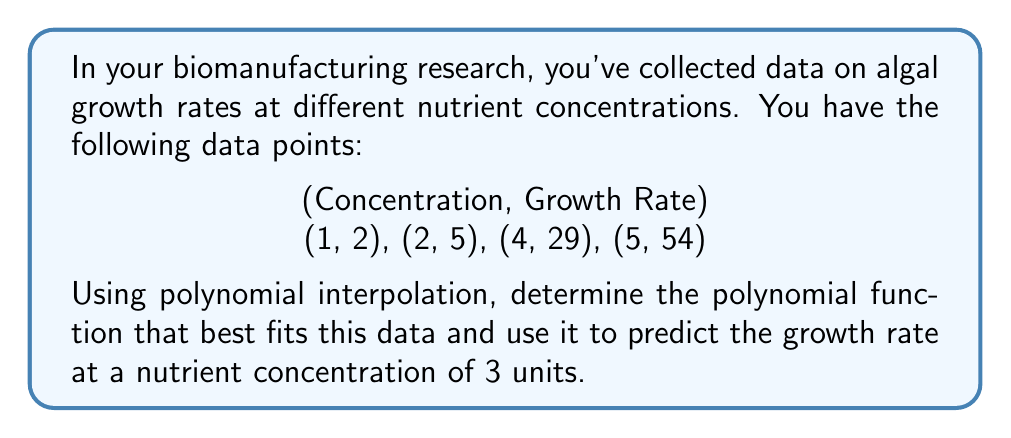Teach me how to tackle this problem. To solve this problem, we'll use Lagrange polynomial interpolation:

1) The Lagrange polynomial is given by:
   $$P(x) = \sum_{i=1}^n y_i \cdot L_i(x)$$
   where $L_i(x)$ is the Lagrange basis polynomial:
   $$L_i(x) = \prod_{j=1, j \neq i}^n \frac{x - x_j}{x_i - x_j}$$

2) Calculate each $L_i(x)$:
   $$L_1(x) = \frac{(x-2)(x-4)(x-5)}{(1-2)(1-4)(1-5)} = -\frac{(x-2)(x-4)(x-5)}{18}$$
   $$L_2(x) = \frac{(x-1)(x-4)(x-5)}{(2-1)(2-4)(2-5)} = \frac{(x-1)(x-4)(x-5)}{6}$$
   $$L_3(x) = \frac{(x-1)(x-2)(x-5)}{(4-1)(4-2)(4-5)} = -\frac{(x-1)(x-2)(x-5)}{6}$$
   $$L_4(x) = \frac{(x-1)(x-2)(x-4)}{(5-1)(5-2)(5-4)} = \frac{(x-1)(x-2)(x-4)}{24}$$

3) Construct the polynomial:
   $$P(x) = 2L_1(x) + 5L_2(x) + 29L_3(x) + 54L_4(x)$$

4) Simplify (this step is typically done by computer):
   $$P(x) = \frac{1}{6}x^3 - \frac{1}{2}x^2 - \frac{7}{3}x + 6$$

5) To find the growth rate at x = 3, evaluate P(3):
   $$P(3) = \frac{1}{6}(3^3) - \frac{1}{2}(3^2) - \frac{7}{3}(3) + 6 = 14$$

Therefore, the predicted growth rate at a nutrient concentration of 3 units is 14.
Answer: 14 